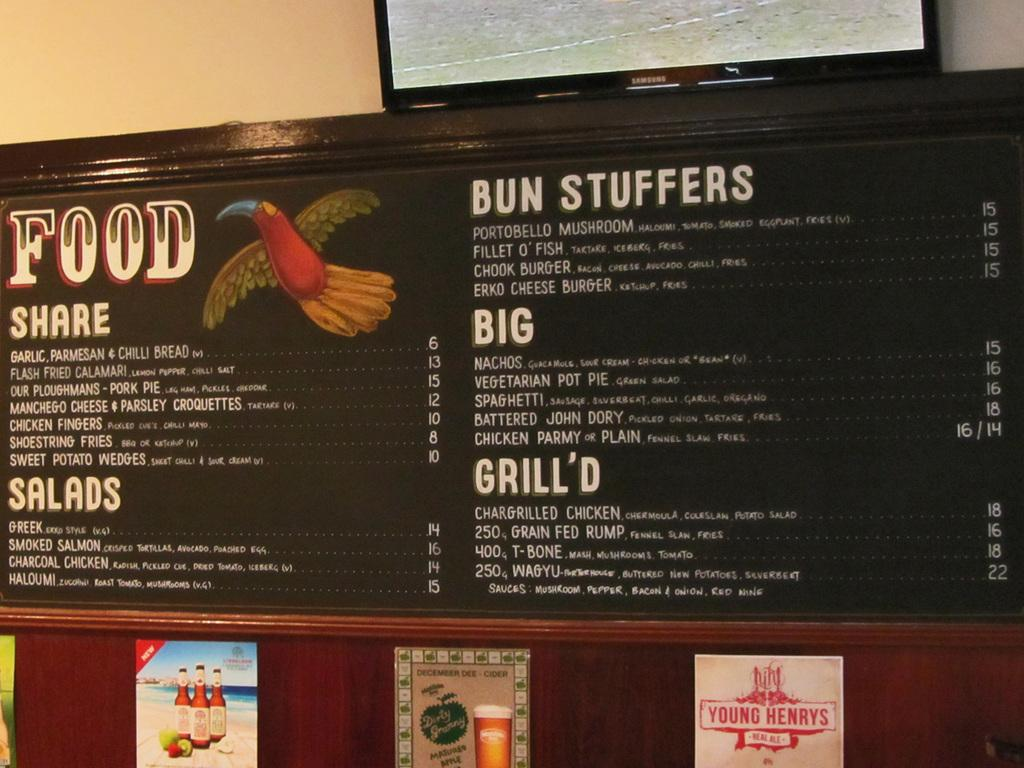<image>
Describe the image concisely. A food menu at a restaurant showing a variety of food and prices. 